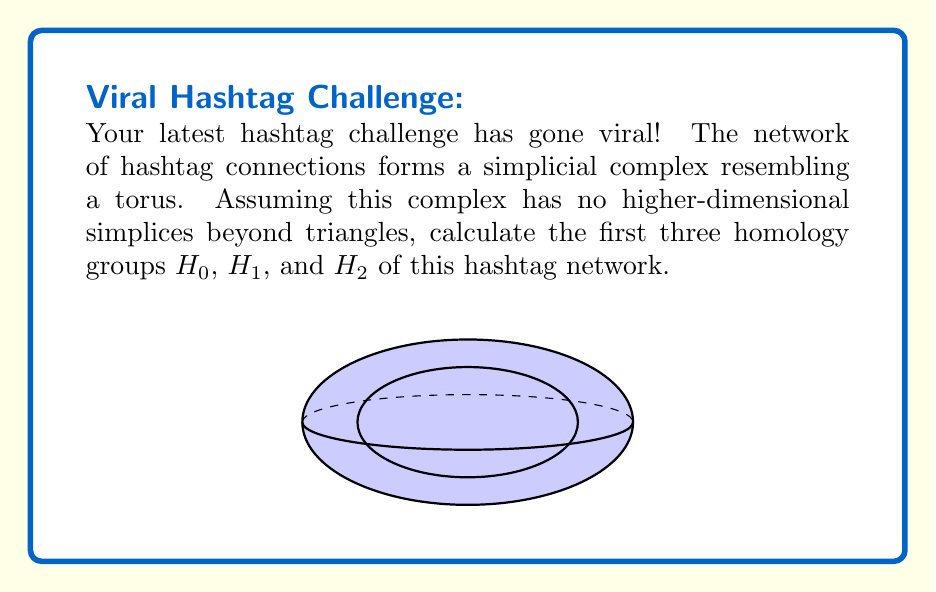Help me with this question. Let's approach this step-by-step:

1) First, recall that a torus is a 2-dimensional surface embedded in 3-dimensional space. It has the shape of a donut.

2) For a simplicial complex homeomorphic to a torus with no higher-dimensional simplices beyond triangles:

   a) $H_0$ represents the number of connected components.
   b) $H_1$ represents the number of 1-dimensional holes (loops).
   c) $H_2$ represents the number of 2-dimensional voids (cavities).

3) For a torus:
   
   a) It is a single connected component, so $H_0 \cong \mathbb{Z}$.
   
   b) It has two independent non-contractible loops: one around the "tube" and one through the "hole". Thus, $H_1 \cong \mathbb{Z} \oplus \mathbb{Z}$.
   
   c) It encloses a single void, so $H_2 \cong \mathbb{Z}$.

4) Therefore, the homology groups are:

   $H_0(T) \cong \mathbb{Z}$
   $H_1(T) \cong \mathbb{Z} \oplus \mathbb{Z}$
   $H_2(T) \cong \mathbb{Z}$

Where $T$ represents the torus.
Answer: $H_0 \cong \mathbb{Z}$, $H_1 \cong \mathbb{Z} \oplus \mathbb{Z}$, $H_2 \cong \mathbb{Z}$ 